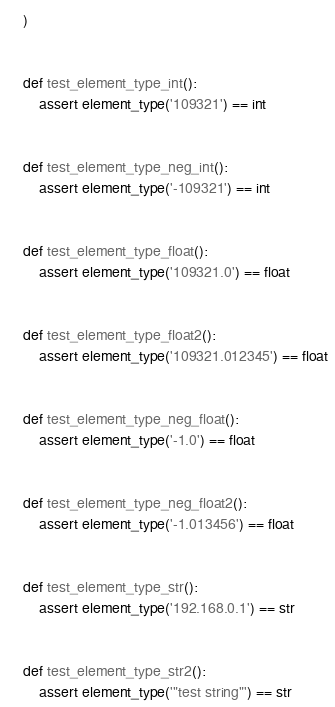Convert code to text. <code><loc_0><loc_0><loc_500><loc_500><_Python_>)


def test_element_type_int():
    assert element_type('109321') == int


def test_element_type_neg_int():
    assert element_type('-109321') == int


def test_element_type_float():
    assert element_type('109321.0') == float


def test_element_type_float2():
    assert element_type('109321.012345') == float


def test_element_type_neg_float():
    assert element_type('-1.0') == float


def test_element_type_neg_float2():
    assert element_type('-1.013456') == float


def test_element_type_str():
    assert element_type('192.168.0.1') == str


def test_element_type_str2():
    assert element_type('"test string"') == str
</code> 